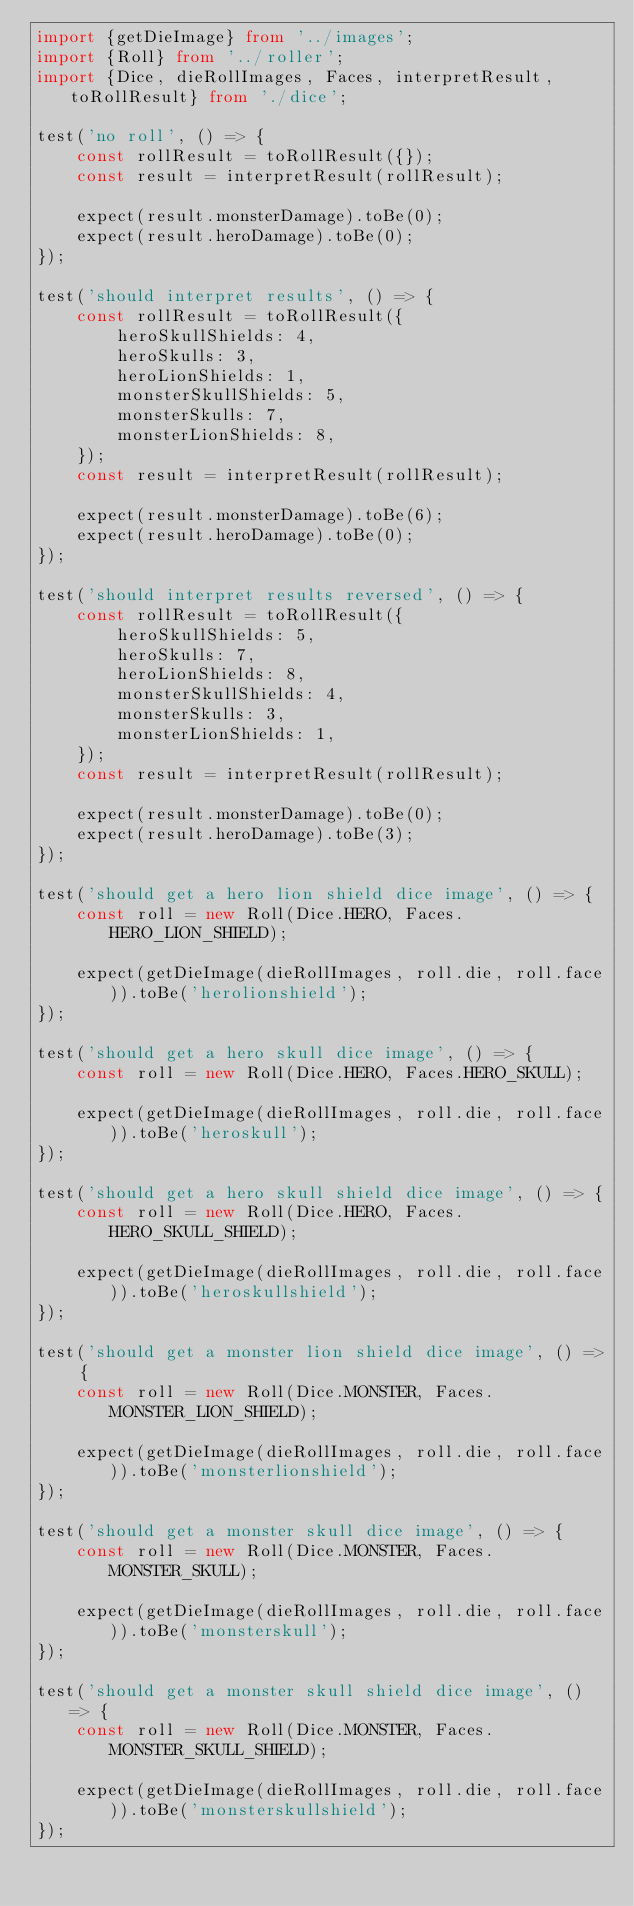Convert code to text. <code><loc_0><loc_0><loc_500><loc_500><_TypeScript_>import {getDieImage} from '../images';
import {Roll} from '../roller';
import {Dice, dieRollImages, Faces, interpretResult, toRollResult} from './dice';

test('no roll', () => {
    const rollResult = toRollResult({});
    const result = interpretResult(rollResult);

    expect(result.monsterDamage).toBe(0);
    expect(result.heroDamage).toBe(0);
});

test('should interpret results', () => {
    const rollResult = toRollResult({
        heroSkullShields: 4,
        heroSkulls: 3,
        heroLionShields: 1,
        monsterSkullShields: 5,
        monsterSkulls: 7,
        monsterLionShields: 8,
    });
    const result = interpretResult(rollResult);

    expect(result.monsterDamage).toBe(6);
    expect(result.heroDamage).toBe(0);
});

test('should interpret results reversed', () => {
    const rollResult = toRollResult({
        heroSkullShields: 5,
        heroSkulls: 7,
        heroLionShields: 8,
        monsterSkullShields: 4,
        monsterSkulls: 3,
        monsterLionShields: 1,
    });
    const result = interpretResult(rollResult);

    expect(result.monsterDamage).toBe(0);
    expect(result.heroDamage).toBe(3);
});

test('should get a hero lion shield dice image', () => {
    const roll = new Roll(Dice.HERO, Faces.HERO_LION_SHIELD);

    expect(getDieImage(dieRollImages, roll.die, roll.face)).toBe('herolionshield');
});

test('should get a hero skull dice image', () => {
    const roll = new Roll(Dice.HERO, Faces.HERO_SKULL);

    expect(getDieImage(dieRollImages, roll.die, roll.face)).toBe('heroskull');
});

test('should get a hero skull shield dice image', () => {
    const roll = new Roll(Dice.HERO, Faces.HERO_SKULL_SHIELD);

    expect(getDieImage(dieRollImages, roll.die, roll.face)).toBe('heroskullshield');
});

test('should get a monster lion shield dice image', () => {
    const roll = new Roll(Dice.MONSTER, Faces.MONSTER_LION_SHIELD);

    expect(getDieImage(dieRollImages, roll.die, roll.face)).toBe('monsterlionshield');
});

test('should get a monster skull dice image', () => {
    const roll = new Roll(Dice.MONSTER, Faces.MONSTER_SKULL);

    expect(getDieImage(dieRollImages, roll.die, roll.face)).toBe('monsterskull');
});

test('should get a monster skull shield dice image', () => {
    const roll = new Roll(Dice.MONSTER, Faces.MONSTER_SKULL_SHIELD);

    expect(getDieImage(dieRollImages, roll.die, roll.face)).toBe('monsterskullshield');
});
</code> 